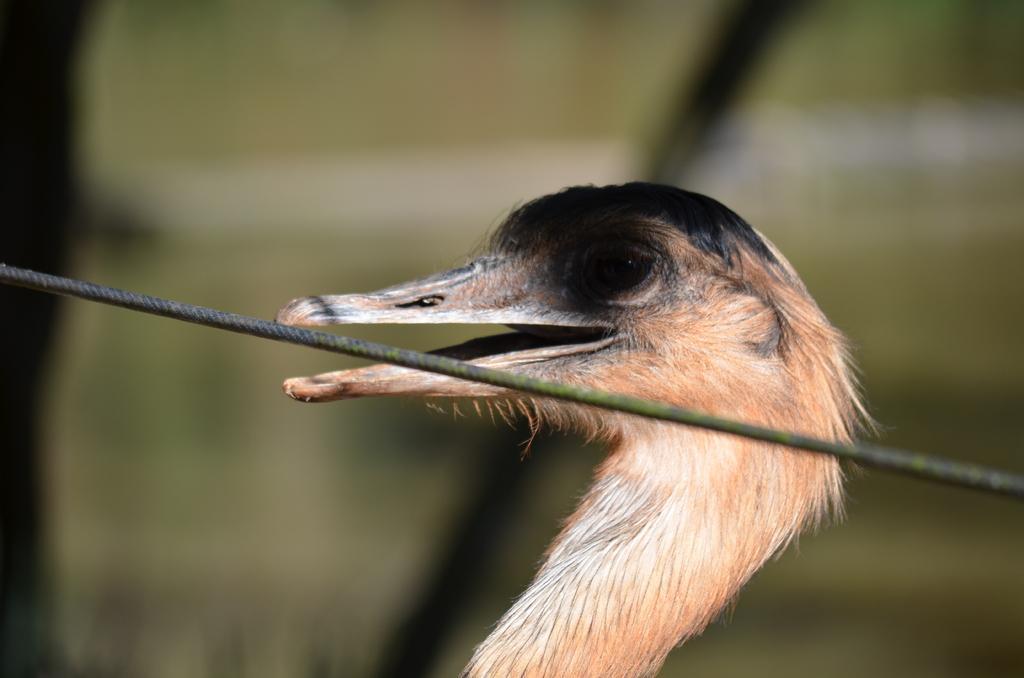Describe this image in one or two sentences. In the middle of this image, there is a thread. Behind this thread, there is a bird, having opened its mouth. And the background is blurred. 